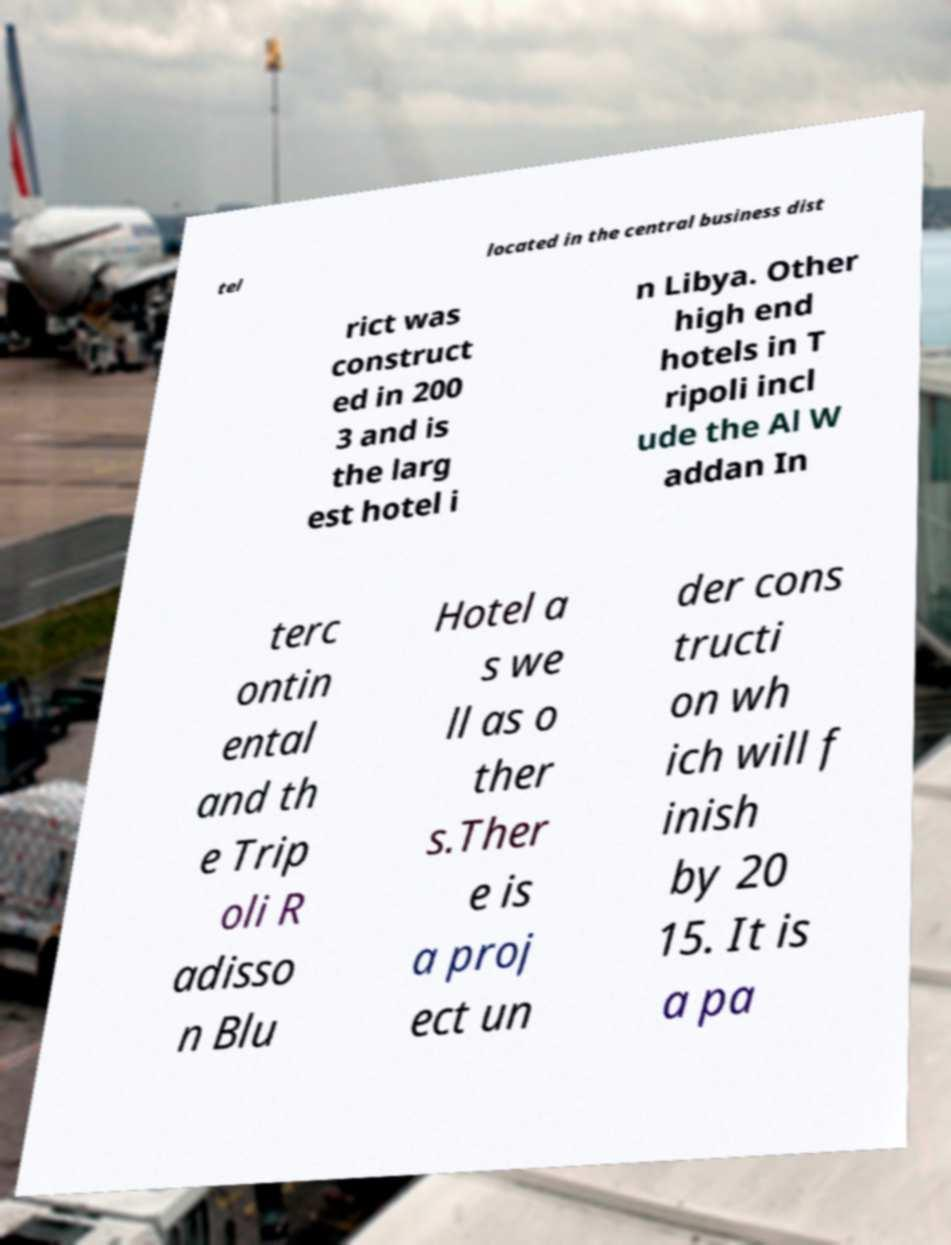Can you read and provide the text displayed in the image?This photo seems to have some interesting text. Can you extract and type it out for me? tel located in the central business dist rict was construct ed in 200 3 and is the larg est hotel i n Libya. Other high end hotels in T ripoli incl ude the Al W addan In terc ontin ental and th e Trip oli R adisso n Blu Hotel a s we ll as o ther s.Ther e is a proj ect un der cons tructi on wh ich will f inish by 20 15. It is a pa 